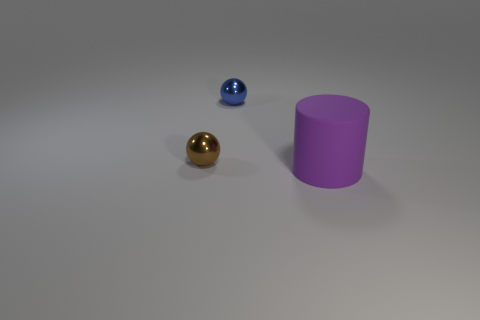Are there an equal number of big rubber cylinders that are in front of the brown thing and large purple matte cylinders?
Give a very brief answer. Yes. What number of small brown metallic spheres are behind the matte cylinder?
Ensure brevity in your answer.  1. The blue metal ball is what size?
Give a very brief answer. Small. What color is the other small object that is made of the same material as the blue object?
Your response must be concise. Brown. What number of other things have the same size as the purple thing?
Provide a succinct answer. 0. Is the material of the object that is in front of the small brown metal sphere the same as the blue object?
Ensure brevity in your answer.  No. Are there fewer large cylinders behind the brown object than metal cylinders?
Offer a very short reply. No. There is a small metal thing that is to the left of the tiny blue ball; what is its shape?
Your answer should be very brief. Sphere. Is there another object of the same shape as the tiny brown object?
Your response must be concise. Yes. Is the shape of the small object that is to the right of the brown metallic sphere the same as the object that is in front of the brown metallic object?
Offer a terse response. No. 